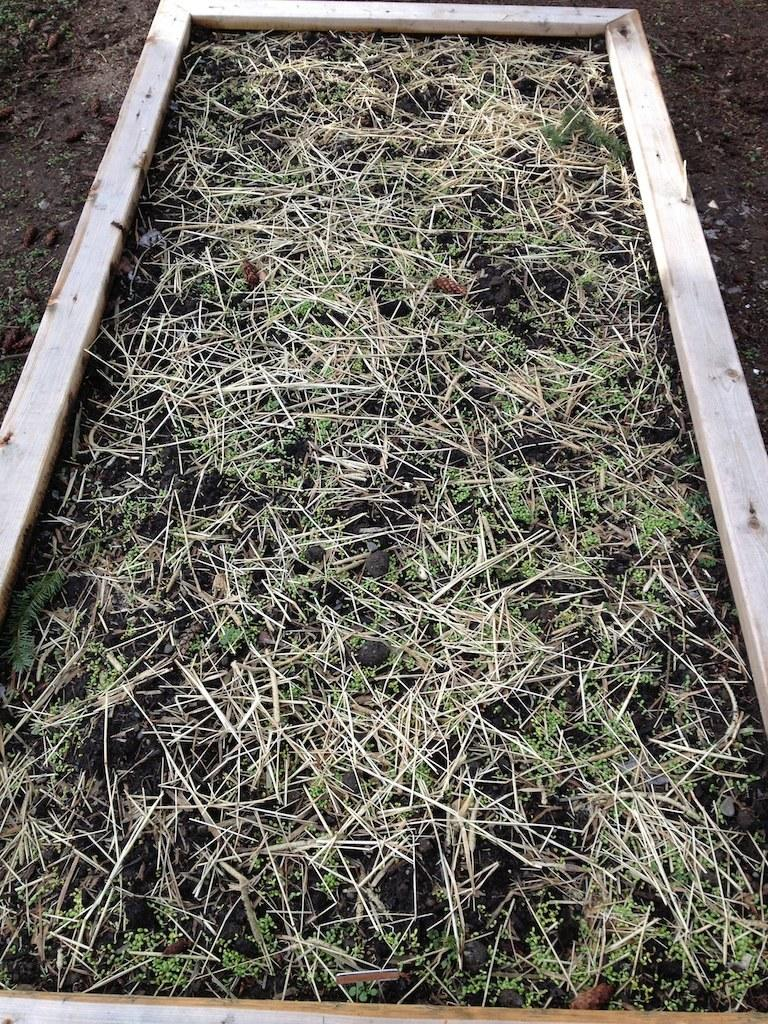What type of tray is visible in the image? There is a wooden tray in the image. What is contained within the wooden tray? The wooden tray contains grass and soil. What type of shirt is visible in the image? There is no shirt present in the image; it features a wooden tray with grass and soil. How many screws can be seen holding the wooden tray together in the image? There are no screws visible in the image, as it only shows a wooden tray with grass and soil. 